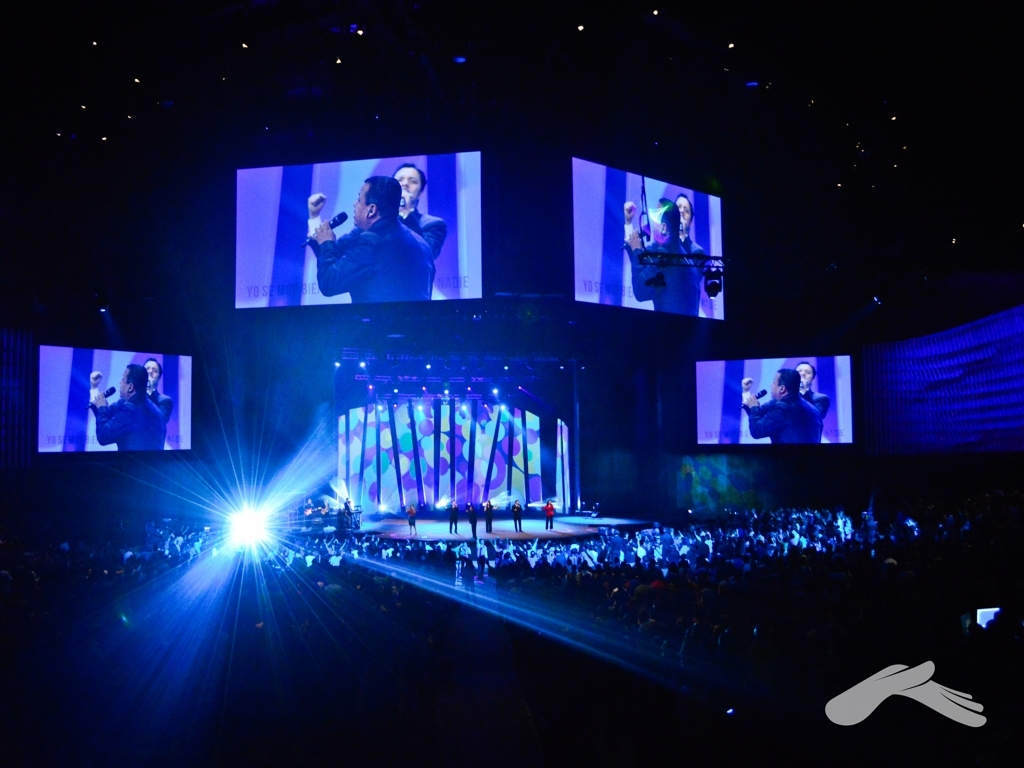What technical aspects contribute to the quality of this show? Several technical aspects contribute to the quality of this event: The strategic lighting enhances visibility and directs the audience's focus, the large screens offer multiple viewing angles for better accessibility, and the sound equipment, which is not directly visible in the image, is assumed to be of professional quality to match the visual experience. Are there any aspects that could be improved for future events? Without knowing the full context of the event, it's challenging to suggest improvements. However, potential areas to consider might include increasing the visibility of the audience to foster a more interactive atmosphere, or incorporating varied multimedia elements to enhance the visual appeal. 